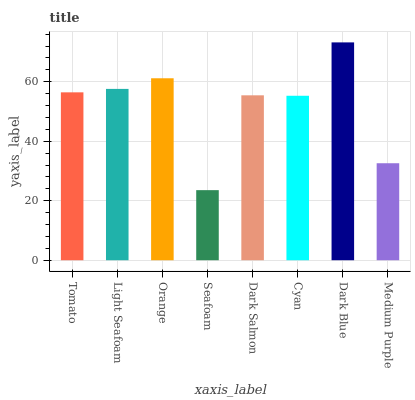Is Seafoam the minimum?
Answer yes or no. Yes. Is Dark Blue the maximum?
Answer yes or no. Yes. Is Light Seafoam the minimum?
Answer yes or no. No. Is Light Seafoam the maximum?
Answer yes or no. No. Is Light Seafoam greater than Tomato?
Answer yes or no. Yes. Is Tomato less than Light Seafoam?
Answer yes or no. Yes. Is Tomato greater than Light Seafoam?
Answer yes or no. No. Is Light Seafoam less than Tomato?
Answer yes or no. No. Is Tomato the high median?
Answer yes or no. Yes. Is Dark Salmon the low median?
Answer yes or no. Yes. Is Cyan the high median?
Answer yes or no. No. Is Cyan the low median?
Answer yes or no. No. 